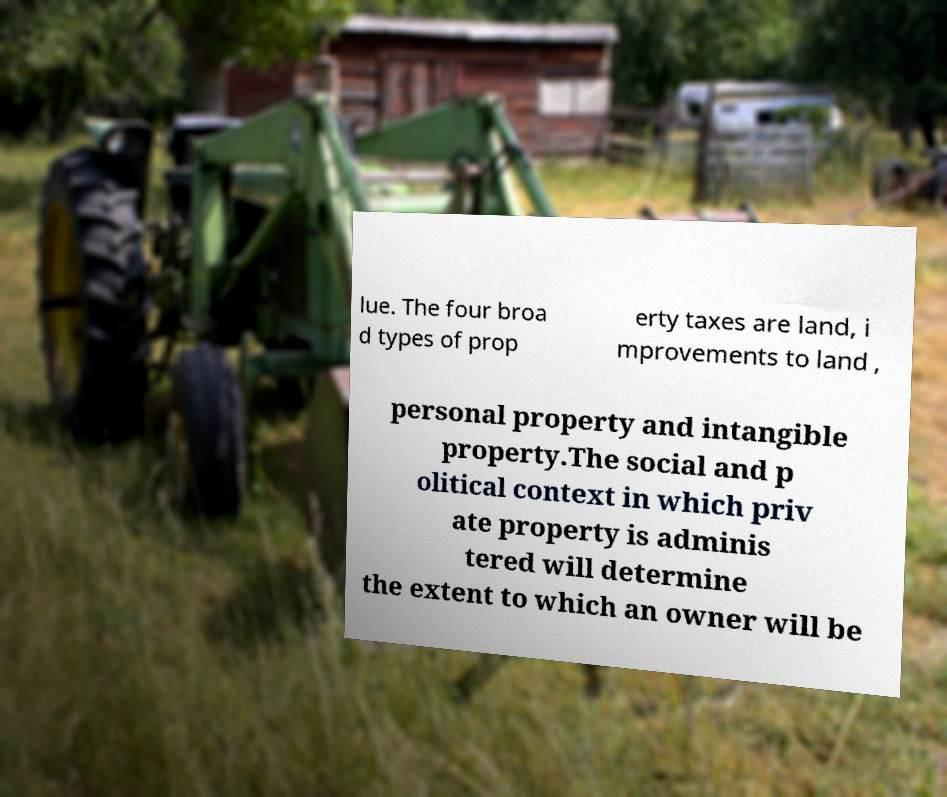I need the written content from this picture converted into text. Can you do that? lue. The four broa d types of prop erty taxes are land, i mprovements to land , personal property and intangible property.The social and p olitical context in which priv ate property is adminis tered will determine the extent to which an owner will be 